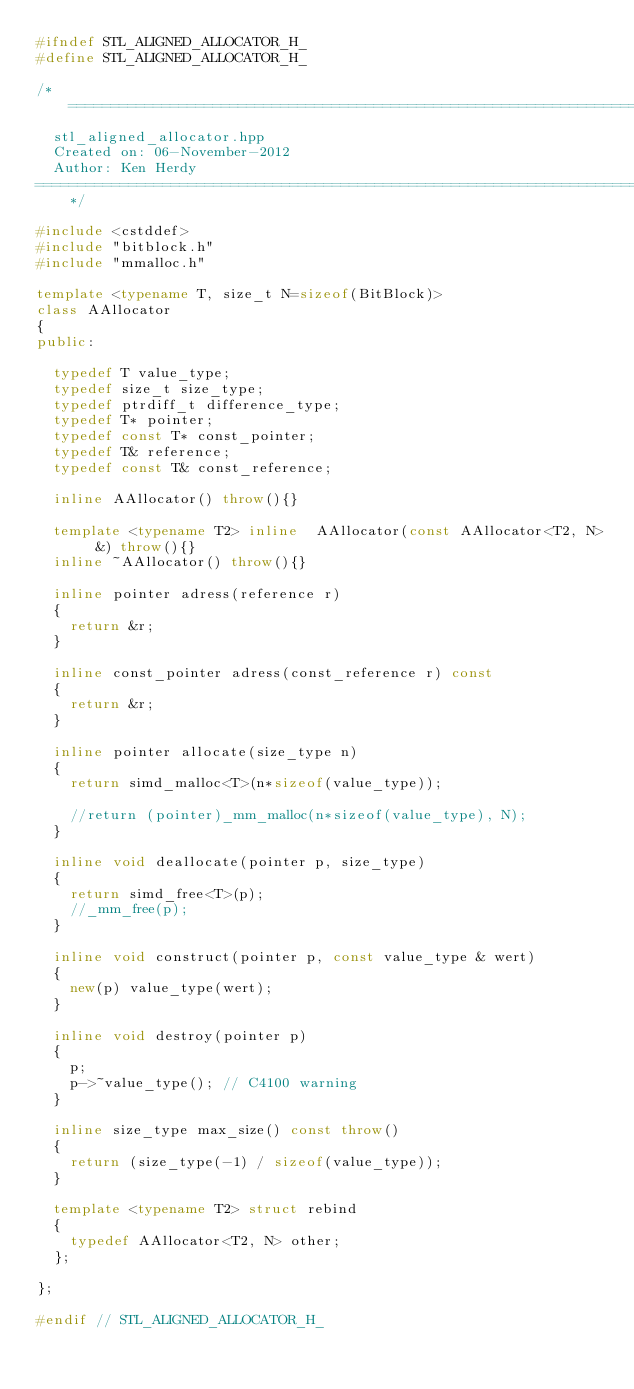Convert code to text. <code><loc_0><loc_0><loc_500><loc_500><_C++_>#ifndef STL_ALIGNED_ALLOCATOR_H_
#define STL_ALIGNED_ALLOCATOR_H_

/*=============================================================================
  stl_aligned_allocator.hpp 
  Created on: 06-November-2012
  Author: Ken Herdy
=============================================================================*/

#include <cstddef>
#include "bitblock.h"
#include "mmalloc.h"

template <typename T, size_t N=sizeof(BitBlock)>
class AAllocator
{
public:

	typedef	T	value_type;
	typedef	size_t size_type;
	typedef	ptrdiff_t difference_type;
	typedef	T* pointer;
	typedef const T* const_pointer;
	typedef	T& reference;
	typedef const T& const_reference;

	inline AAllocator() throw(){}

	template <typename T2> inline  AAllocator(const AAllocator<T2, N> &) throw(){}
	inline ~AAllocator() throw(){}	

	inline pointer adress(reference r)
	{ 
		return &r; 
	}

	inline const_pointer adress(const_reference r) const
	{ 
		return &r; 
	}

	inline pointer allocate(size_type n)
	{ 
		return simd_malloc<T>(n*sizeof(value_type));

		//return (pointer)_mm_malloc(n*sizeof(value_type), N); 
	}

	inline void deallocate(pointer p, size_type)
	{ 
		return simd_free<T>(p); 
		//_mm_free(p); 
	}

	inline void construct(pointer p, const value_type & wert)	
	{ 
		new(p) value_type(wert); 
	}

	inline void destroy(pointer p)
	{ 
		p; 
		p->~value_type(); // C4100 warning
	}

	inline size_type max_size() const throw()
	{ 
		return (size_type(-1) / sizeof(value_type)); 
	}

	template <typename T2> struct rebind 
	{ 
		typedef AAllocator<T2, N> other; 
	};

};

#endif // STL_ALIGNED_ALLOCATOR_H_ 
</code> 